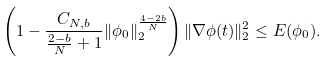Convert formula to latex. <formula><loc_0><loc_0><loc_500><loc_500>\left ( 1 - \frac { C _ { N , b } } { \frac { 2 - b } { N } + 1 } \| \phi _ { 0 } \| _ { 2 } ^ { \frac { 4 - 2 b } { N } } \right ) \| \nabla \phi ( t ) \| _ { 2 } ^ { 2 } \leq E ( \phi _ { 0 } ) .</formula> 